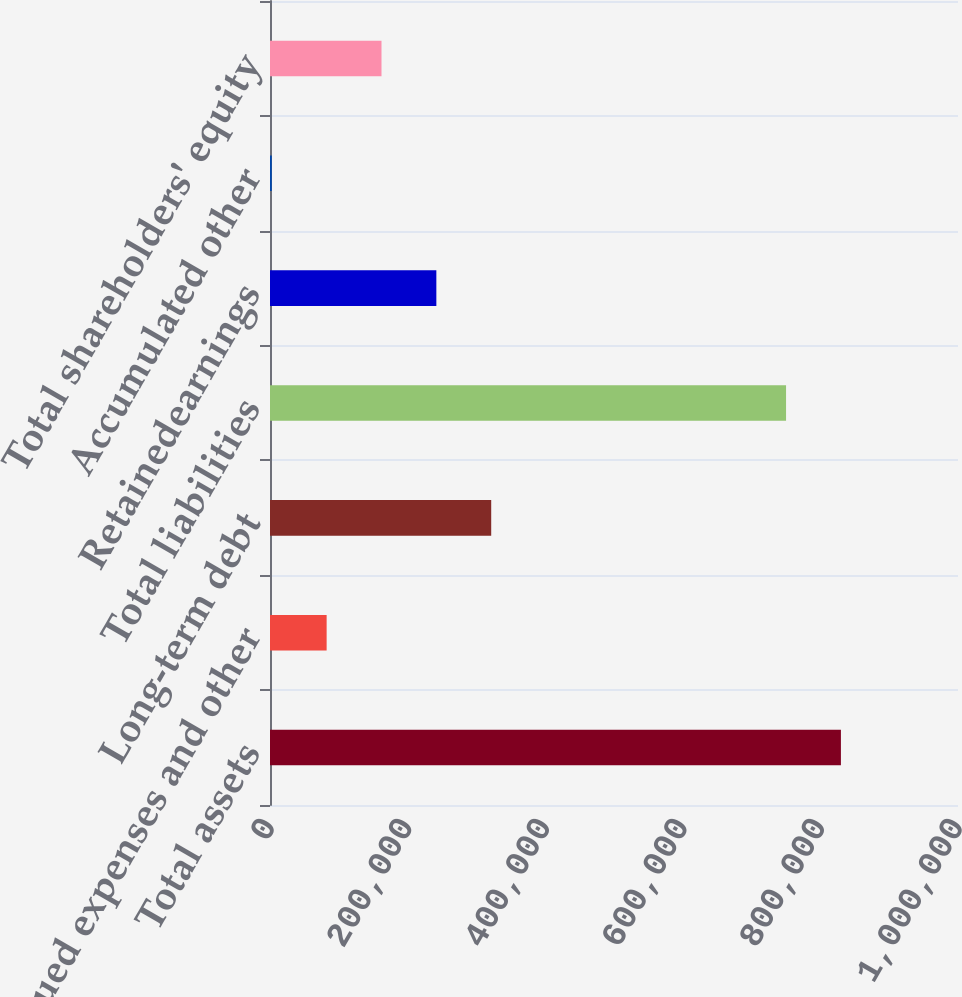Convert chart to OTSL. <chart><loc_0><loc_0><loc_500><loc_500><bar_chart><fcel>Total assets<fcel>Accrued expenses and other<fcel>Long-term debt<fcel>Total liabilities<fcel>Retainedearnings<fcel>Accumulated other<fcel>Total shareholders' equity<nl><fcel>829811<fcel>82318<fcel>321526<fcel>750075<fcel>241790<fcel>2582<fcel>162054<nl></chart> 